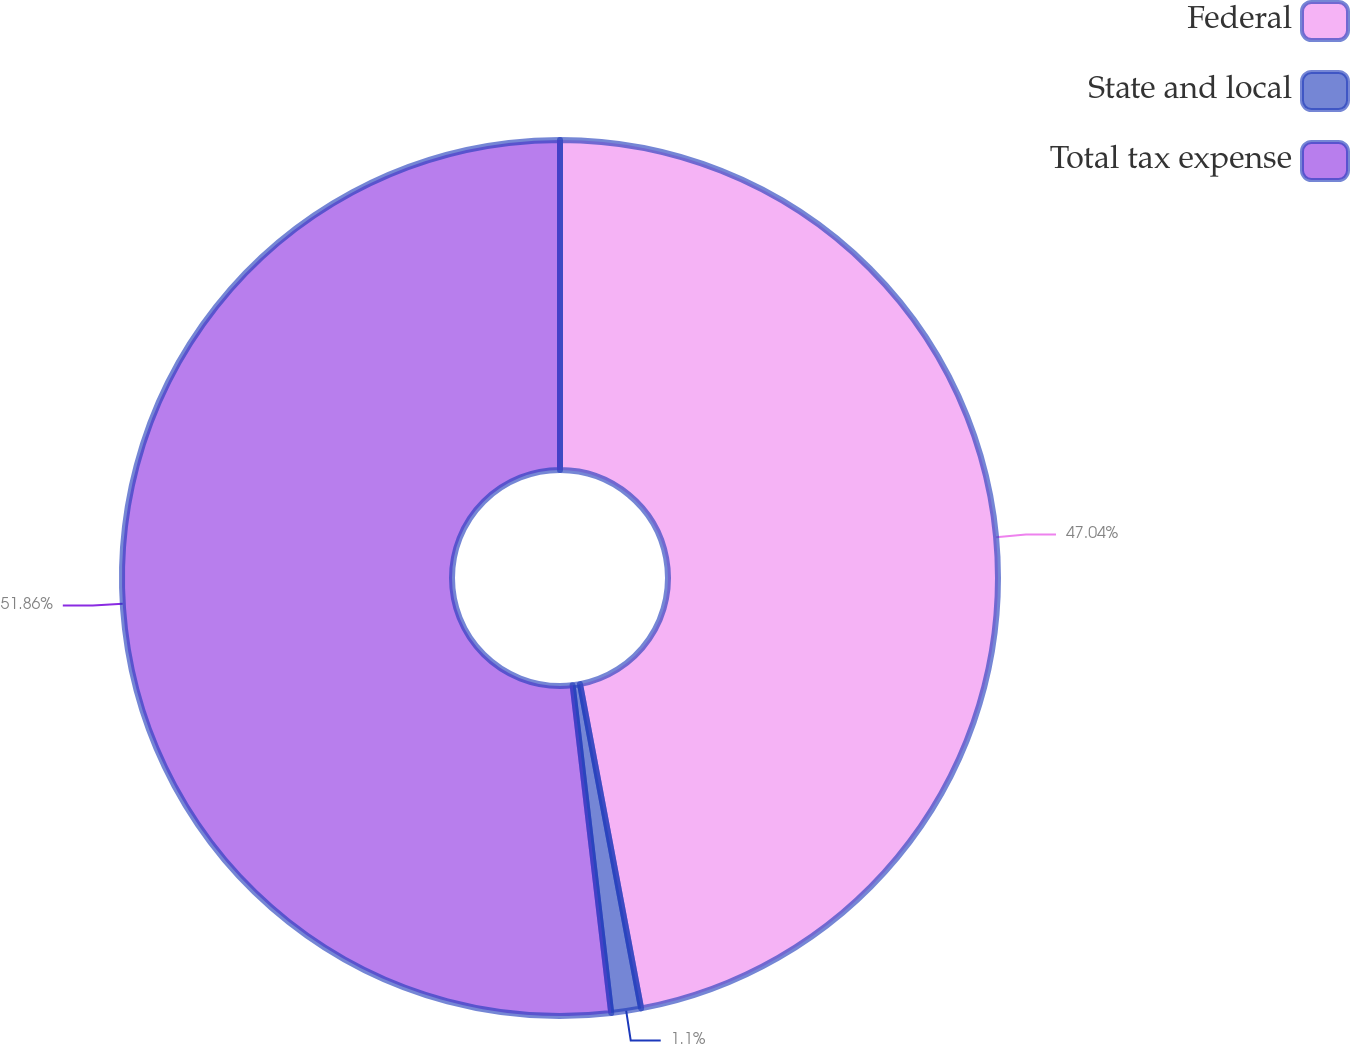Convert chart to OTSL. <chart><loc_0><loc_0><loc_500><loc_500><pie_chart><fcel>Federal<fcel>State and local<fcel>Total tax expense<nl><fcel>47.04%<fcel>1.1%<fcel>51.87%<nl></chart> 